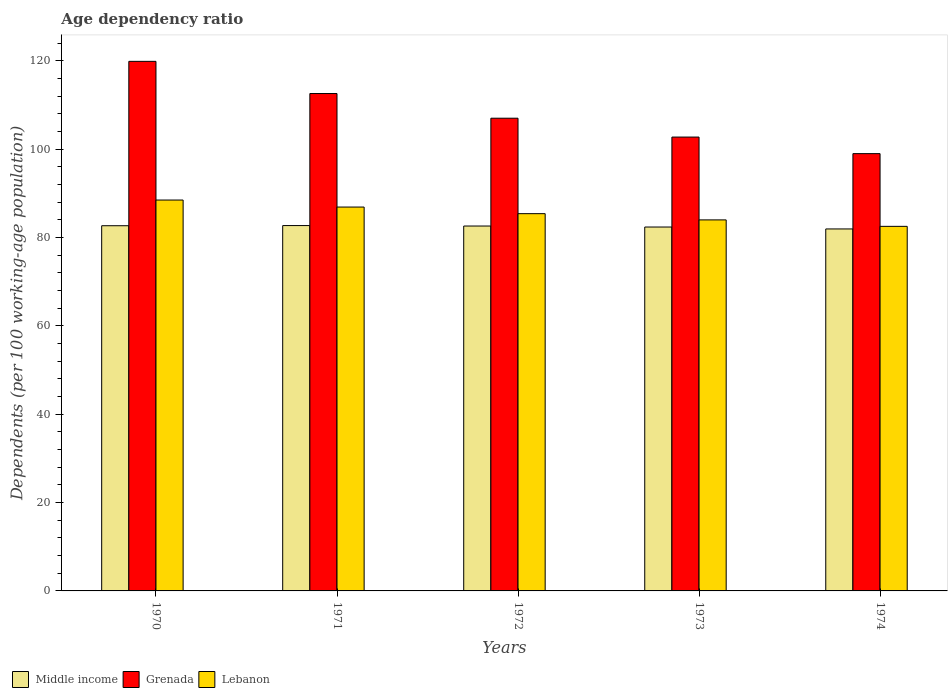How many different coloured bars are there?
Make the answer very short. 3. Are the number of bars per tick equal to the number of legend labels?
Give a very brief answer. Yes. Are the number of bars on each tick of the X-axis equal?
Keep it short and to the point. Yes. How many bars are there on the 4th tick from the right?
Provide a short and direct response. 3. In how many cases, is the number of bars for a given year not equal to the number of legend labels?
Your response must be concise. 0. What is the age dependency ratio in in Grenada in 1970?
Ensure brevity in your answer.  119.88. Across all years, what is the maximum age dependency ratio in in Grenada?
Keep it short and to the point. 119.88. Across all years, what is the minimum age dependency ratio in in Lebanon?
Offer a very short reply. 82.53. In which year was the age dependency ratio in in Lebanon minimum?
Provide a short and direct response. 1974. What is the total age dependency ratio in in Middle income in the graph?
Provide a short and direct response. 412.28. What is the difference between the age dependency ratio in in Middle income in 1972 and that in 1974?
Ensure brevity in your answer.  0.66. What is the difference between the age dependency ratio in in Lebanon in 1974 and the age dependency ratio in in Middle income in 1970?
Provide a short and direct response. -0.14. What is the average age dependency ratio in in Lebanon per year?
Make the answer very short. 85.46. In the year 1974, what is the difference between the age dependency ratio in in Lebanon and age dependency ratio in in Middle income?
Your answer should be compact. 0.59. In how many years, is the age dependency ratio in in Grenada greater than 4 %?
Give a very brief answer. 5. What is the ratio of the age dependency ratio in in Middle income in 1972 to that in 1974?
Ensure brevity in your answer.  1.01. Is the difference between the age dependency ratio in in Lebanon in 1971 and 1974 greater than the difference between the age dependency ratio in in Middle income in 1971 and 1974?
Provide a succinct answer. Yes. What is the difference between the highest and the second highest age dependency ratio in in Middle income?
Ensure brevity in your answer.  0.03. What is the difference between the highest and the lowest age dependency ratio in in Middle income?
Provide a short and direct response. 0.76. In how many years, is the age dependency ratio in in Grenada greater than the average age dependency ratio in in Grenada taken over all years?
Your answer should be very brief. 2. What does the 1st bar from the left in 1972 represents?
Provide a short and direct response. Middle income. Are all the bars in the graph horizontal?
Your response must be concise. No. How many years are there in the graph?
Provide a short and direct response. 5. What is the difference between two consecutive major ticks on the Y-axis?
Ensure brevity in your answer.  20. Does the graph contain any zero values?
Give a very brief answer. No. Where does the legend appear in the graph?
Give a very brief answer. Bottom left. What is the title of the graph?
Offer a very short reply. Age dependency ratio. Does "Timor-Leste" appear as one of the legend labels in the graph?
Keep it short and to the point. No. What is the label or title of the X-axis?
Your answer should be compact. Years. What is the label or title of the Y-axis?
Offer a very short reply. Dependents (per 100 working-age population). What is the Dependents (per 100 working-age population) of Middle income in 1970?
Make the answer very short. 82.67. What is the Dependents (per 100 working-age population) of Grenada in 1970?
Offer a very short reply. 119.88. What is the Dependents (per 100 working-age population) of Lebanon in 1970?
Make the answer very short. 88.48. What is the Dependents (per 100 working-age population) in Middle income in 1971?
Provide a short and direct response. 82.7. What is the Dependents (per 100 working-age population) of Grenada in 1971?
Offer a very short reply. 112.59. What is the Dependents (per 100 working-age population) of Lebanon in 1971?
Keep it short and to the point. 86.89. What is the Dependents (per 100 working-age population) of Middle income in 1972?
Your answer should be very brief. 82.6. What is the Dependents (per 100 working-age population) of Grenada in 1972?
Your answer should be very brief. 107.01. What is the Dependents (per 100 working-age population) in Lebanon in 1972?
Ensure brevity in your answer.  85.4. What is the Dependents (per 100 working-age population) in Middle income in 1973?
Provide a succinct answer. 82.37. What is the Dependents (per 100 working-age population) in Grenada in 1973?
Offer a very short reply. 102.73. What is the Dependents (per 100 working-age population) in Lebanon in 1973?
Give a very brief answer. 83.99. What is the Dependents (per 100 working-age population) in Middle income in 1974?
Provide a short and direct response. 81.94. What is the Dependents (per 100 working-age population) of Grenada in 1974?
Offer a very short reply. 98.99. What is the Dependents (per 100 working-age population) of Lebanon in 1974?
Keep it short and to the point. 82.53. Across all years, what is the maximum Dependents (per 100 working-age population) of Middle income?
Offer a very short reply. 82.7. Across all years, what is the maximum Dependents (per 100 working-age population) of Grenada?
Give a very brief answer. 119.88. Across all years, what is the maximum Dependents (per 100 working-age population) of Lebanon?
Provide a short and direct response. 88.48. Across all years, what is the minimum Dependents (per 100 working-age population) in Middle income?
Make the answer very short. 81.94. Across all years, what is the minimum Dependents (per 100 working-age population) of Grenada?
Offer a terse response. 98.99. Across all years, what is the minimum Dependents (per 100 working-age population) in Lebanon?
Keep it short and to the point. 82.53. What is the total Dependents (per 100 working-age population) of Middle income in the graph?
Keep it short and to the point. 412.28. What is the total Dependents (per 100 working-age population) in Grenada in the graph?
Your answer should be compact. 541.19. What is the total Dependents (per 100 working-age population) of Lebanon in the graph?
Your response must be concise. 427.29. What is the difference between the Dependents (per 100 working-age population) in Middle income in 1970 and that in 1971?
Provide a short and direct response. -0.03. What is the difference between the Dependents (per 100 working-age population) of Grenada in 1970 and that in 1971?
Keep it short and to the point. 7.28. What is the difference between the Dependents (per 100 working-age population) of Lebanon in 1970 and that in 1971?
Provide a short and direct response. 1.59. What is the difference between the Dependents (per 100 working-age population) in Middle income in 1970 and that in 1972?
Your response must be concise. 0.07. What is the difference between the Dependents (per 100 working-age population) of Grenada in 1970 and that in 1972?
Your answer should be very brief. 12.87. What is the difference between the Dependents (per 100 working-age population) of Lebanon in 1970 and that in 1972?
Make the answer very short. 3.08. What is the difference between the Dependents (per 100 working-age population) in Middle income in 1970 and that in 1973?
Provide a succinct answer. 0.29. What is the difference between the Dependents (per 100 working-age population) of Grenada in 1970 and that in 1973?
Provide a succinct answer. 17.14. What is the difference between the Dependents (per 100 working-age population) in Lebanon in 1970 and that in 1973?
Provide a succinct answer. 4.5. What is the difference between the Dependents (per 100 working-age population) in Middle income in 1970 and that in 1974?
Your response must be concise. 0.73. What is the difference between the Dependents (per 100 working-age population) of Grenada in 1970 and that in 1974?
Give a very brief answer. 20.89. What is the difference between the Dependents (per 100 working-age population) of Lebanon in 1970 and that in 1974?
Provide a succinct answer. 5.96. What is the difference between the Dependents (per 100 working-age population) in Middle income in 1971 and that in 1972?
Keep it short and to the point. 0.1. What is the difference between the Dependents (per 100 working-age population) in Grenada in 1971 and that in 1972?
Your answer should be very brief. 5.59. What is the difference between the Dependents (per 100 working-age population) of Lebanon in 1971 and that in 1972?
Your answer should be compact. 1.49. What is the difference between the Dependents (per 100 working-age population) in Middle income in 1971 and that in 1973?
Make the answer very short. 0.33. What is the difference between the Dependents (per 100 working-age population) in Grenada in 1971 and that in 1973?
Provide a short and direct response. 9.86. What is the difference between the Dependents (per 100 working-age population) in Lebanon in 1971 and that in 1973?
Keep it short and to the point. 2.91. What is the difference between the Dependents (per 100 working-age population) of Middle income in 1971 and that in 1974?
Ensure brevity in your answer.  0.76. What is the difference between the Dependents (per 100 working-age population) in Grenada in 1971 and that in 1974?
Keep it short and to the point. 13.61. What is the difference between the Dependents (per 100 working-age population) in Lebanon in 1971 and that in 1974?
Give a very brief answer. 4.37. What is the difference between the Dependents (per 100 working-age population) in Middle income in 1972 and that in 1973?
Offer a terse response. 0.23. What is the difference between the Dependents (per 100 working-age population) in Grenada in 1972 and that in 1973?
Make the answer very short. 4.27. What is the difference between the Dependents (per 100 working-age population) in Lebanon in 1972 and that in 1973?
Provide a succinct answer. 1.41. What is the difference between the Dependents (per 100 working-age population) of Middle income in 1972 and that in 1974?
Offer a very short reply. 0.66. What is the difference between the Dependents (per 100 working-age population) in Grenada in 1972 and that in 1974?
Your response must be concise. 8.02. What is the difference between the Dependents (per 100 working-age population) in Lebanon in 1972 and that in 1974?
Your answer should be very brief. 2.87. What is the difference between the Dependents (per 100 working-age population) in Middle income in 1973 and that in 1974?
Your answer should be very brief. 0.43. What is the difference between the Dependents (per 100 working-age population) of Grenada in 1973 and that in 1974?
Provide a succinct answer. 3.75. What is the difference between the Dependents (per 100 working-age population) of Lebanon in 1973 and that in 1974?
Ensure brevity in your answer.  1.46. What is the difference between the Dependents (per 100 working-age population) of Middle income in 1970 and the Dependents (per 100 working-age population) of Grenada in 1971?
Offer a very short reply. -29.92. What is the difference between the Dependents (per 100 working-age population) of Middle income in 1970 and the Dependents (per 100 working-age population) of Lebanon in 1971?
Your response must be concise. -4.23. What is the difference between the Dependents (per 100 working-age population) in Grenada in 1970 and the Dependents (per 100 working-age population) in Lebanon in 1971?
Your response must be concise. 32.98. What is the difference between the Dependents (per 100 working-age population) of Middle income in 1970 and the Dependents (per 100 working-age population) of Grenada in 1972?
Offer a terse response. -24.34. What is the difference between the Dependents (per 100 working-age population) of Middle income in 1970 and the Dependents (per 100 working-age population) of Lebanon in 1972?
Ensure brevity in your answer.  -2.73. What is the difference between the Dependents (per 100 working-age population) in Grenada in 1970 and the Dependents (per 100 working-age population) in Lebanon in 1972?
Provide a succinct answer. 34.48. What is the difference between the Dependents (per 100 working-age population) in Middle income in 1970 and the Dependents (per 100 working-age population) in Grenada in 1973?
Offer a very short reply. -20.07. What is the difference between the Dependents (per 100 working-age population) of Middle income in 1970 and the Dependents (per 100 working-age population) of Lebanon in 1973?
Make the answer very short. -1.32. What is the difference between the Dependents (per 100 working-age population) of Grenada in 1970 and the Dependents (per 100 working-age population) of Lebanon in 1973?
Ensure brevity in your answer.  35.89. What is the difference between the Dependents (per 100 working-age population) of Middle income in 1970 and the Dependents (per 100 working-age population) of Grenada in 1974?
Offer a terse response. -16.32. What is the difference between the Dependents (per 100 working-age population) in Middle income in 1970 and the Dependents (per 100 working-age population) in Lebanon in 1974?
Your answer should be compact. 0.14. What is the difference between the Dependents (per 100 working-age population) of Grenada in 1970 and the Dependents (per 100 working-age population) of Lebanon in 1974?
Ensure brevity in your answer.  37.35. What is the difference between the Dependents (per 100 working-age population) of Middle income in 1971 and the Dependents (per 100 working-age population) of Grenada in 1972?
Your answer should be compact. -24.3. What is the difference between the Dependents (per 100 working-age population) of Middle income in 1971 and the Dependents (per 100 working-age population) of Lebanon in 1972?
Your response must be concise. -2.7. What is the difference between the Dependents (per 100 working-age population) in Grenada in 1971 and the Dependents (per 100 working-age population) in Lebanon in 1972?
Offer a very short reply. 27.19. What is the difference between the Dependents (per 100 working-age population) of Middle income in 1971 and the Dependents (per 100 working-age population) of Grenada in 1973?
Give a very brief answer. -20.03. What is the difference between the Dependents (per 100 working-age population) in Middle income in 1971 and the Dependents (per 100 working-age population) in Lebanon in 1973?
Give a very brief answer. -1.28. What is the difference between the Dependents (per 100 working-age population) of Grenada in 1971 and the Dependents (per 100 working-age population) of Lebanon in 1973?
Keep it short and to the point. 28.61. What is the difference between the Dependents (per 100 working-age population) of Middle income in 1971 and the Dependents (per 100 working-age population) of Grenada in 1974?
Offer a very short reply. -16.28. What is the difference between the Dependents (per 100 working-age population) in Middle income in 1971 and the Dependents (per 100 working-age population) in Lebanon in 1974?
Provide a succinct answer. 0.17. What is the difference between the Dependents (per 100 working-age population) in Grenada in 1971 and the Dependents (per 100 working-age population) in Lebanon in 1974?
Provide a succinct answer. 30.06. What is the difference between the Dependents (per 100 working-age population) in Middle income in 1972 and the Dependents (per 100 working-age population) in Grenada in 1973?
Ensure brevity in your answer.  -20.13. What is the difference between the Dependents (per 100 working-age population) in Middle income in 1972 and the Dependents (per 100 working-age population) in Lebanon in 1973?
Keep it short and to the point. -1.38. What is the difference between the Dependents (per 100 working-age population) of Grenada in 1972 and the Dependents (per 100 working-age population) of Lebanon in 1973?
Provide a succinct answer. 23.02. What is the difference between the Dependents (per 100 working-age population) of Middle income in 1972 and the Dependents (per 100 working-age population) of Grenada in 1974?
Your answer should be very brief. -16.38. What is the difference between the Dependents (per 100 working-age population) in Middle income in 1972 and the Dependents (per 100 working-age population) in Lebanon in 1974?
Give a very brief answer. 0.08. What is the difference between the Dependents (per 100 working-age population) in Grenada in 1972 and the Dependents (per 100 working-age population) in Lebanon in 1974?
Offer a terse response. 24.48. What is the difference between the Dependents (per 100 working-age population) of Middle income in 1973 and the Dependents (per 100 working-age population) of Grenada in 1974?
Your answer should be very brief. -16.61. What is the difference between the Dependents (per 100 working-age population) of Middle income in 1973 and the Dependents (per 100 working-age population) of Lebanon in 1974?
Provide a short and direct response. -0.15. What is the difference between the Dependents (per 100 working-age population) in Grenada in 1973 and the Dependents (per 100 working-age population) in Lebanon in 1974?
Provide a succinct answer. 20.21. What is the average Dependents (per 100 working-age population) of Middle income per year?
Provide a short and direct response. 82.46. What is the average Dependents (per 100 working-age population) of Grenada per year?
Your answer should be very brief. 108.24. What is the average Dependents (per 100 working-age population) in Lebanon per year?
Keep it short and to the point. 85.46. In the year 1970, what is the difference between the Dependents (per 100 working-age population) of Middle income and Dependents (per 100 working-age population) of Grenada?
Your answer should be compact. -37.21. In the year 1970, what is the difference between the Dependents (per 100 working-age population) of Middle income and Dependents (per 100 working-age population) of Lebanon?
Your answer should be compact. -5.82. In the year 1970, what is the difference between the Dependents (per 100 working-age population) of Grenada and Dependents (per 100 working-age population) of Lebanon?
Offer a very short reply. 31.39. In the year 1971, what is the difference between the Dependents (per 100 working-age population) in Middle income and Dependents (per 100 working-age population) in Grenada?
Your answer should be very brief. -29.89. In the year 1971, what is the difference between the Dependents (per 100 working-age population) of Middle income and Dependents (per 100 working-age population) of Lebanon?
Your answer should be compact. -4.19. In the year 1971, what is the difference between the Dependents (per 100 working-age population) in Grenada and Dependents (per 100 working-age population) in Lebanon?
Keep it short and to the point. 25.7. In the year 1972, what is the difference between the Dependents (per 100 working-age population) in Middle income and Dependents (per 100 working-age population) in Grenada?
Your answer should be compact. -24.4. In the year 1972, what is the difference between the Dependents (per 100 working-age population) of Middle income and Dependents (per 100 working-age population) of Lebanon?
Your response must be concise. -2.8. In the year 1972, what is the difference between the Dependents (per 100 working-age population) of Grenada and Dependents (per 100 working-age population) of Lebanon?
Provide a succinct answer. 21.61. In the year 1973, what is the difference between the Dependents (per 100 working-age population) in Middle income and Dependents (per 100 working-age population) in Grenada?
Offer a very short reply. -20.36. In the year 1973, what is the difference between the Dependents (per 100 working-age population) in Middle income and Dependents (per 100 working-age population) in Lebanon?
Give a very brief answer. -1.61. In the year 1973, what is the difference between the Dependents (per 100 working-age population) of Grenada and Dependents (per 100 working-age population) of Lebanon?
Offer a very short reply. 18.75. In the year 1974, what is the difference between the Dependents (per 100 working-age population) in Middle income and Dependents (per 100 working-age population) in Grenada?
Your response must be concise. -17.05. In the year 1974, what is the difference between the Dependents (per 100 working-age population) of Middle income and Dependents (per 100 working-age population) of Lebanon?
Offer a very short reply. -0.59. In the year 1974, what is the difference between the Dependents (per 100 working-age population) of Grenada and Dependents (per 100 working-age population) of Lebanon?
Your answer should be compact. 16.46. What is the ratio of the Dependents (per 100 working-age population) in Grenada in 1970 to that in 1971?
Your answer should be compact. 1.06. What is the ratio of the Dependents (per 100 working-age population) in Lebanon in 1970 to that in 1971?
Your answer should be compact. 1.02. What is the ratio of the Dependents (per 100 working-age population) in Middle income in 1970 to that in 1972?
Give a very brief answer. 1. What is the ratio of the Dependents (per 100 working-age population) of Grenada in 1970 to that in 1972?
Give a very brief answer. 1.12. What is the ratio of the Dependents (per 100 working-age population) of Lebanon in 1970 to that in 1972?
Your answer should be compact. 1.04. What is the ratio of the Dependents (per 100 working-age population) in Grenada in 1970 to that in 1973?
Provide a short and direct response. 1.17. What is the ratio of the Dependents (per 100 working-age population) in Lebanon in 1970 to that in 1973?
Your answer should be very brief. 1.05. What is the ratio of the Dependents (per 100 working-age population) of Middle income in 1970 to that in 1974?
Provide a short and direct response. 1.01. What is the ratio of the Dependents (per 100 working-age population) in Grenada in 1970 to that in 1974?
Keep it short and to the point. 1.21. What is the ratio of the Dependents (per 100 working-age population) of Lebanon in 1970 to that in 1974?
Your answer should be compact. 1.07. What is the ratio of the Dependents (per 100 working-age population) in Grenada in 1971 to that in 1972?
Your answer should be compact. 1.05. What is the ratio of the Dependents (per 100 working-age population) of Lebanon in 1971 to that in 1972?
Make the answer very short. 1.02. What is the ratio of the Dependents (per 100 working-age population) in Middle income in 1971 to that in 1973?
Provide a short and direct response. 1. What is the ratio of the Dependents (per 100 working-age population) of Grenada in 1971 to that in 1973?
Your answer should be compact. 1.1. What is the ratio of the Dependents (per 100 working-age population) in Lebanon in 1971 to that in 1973?
Your answer should be very brief. 1.03. What is the ratio of the Dependents (per 100 working-age population) of Middle income in 1971 to that in 1974?
Your response must be concise. 1.01. What is the ratio of the Dependents (per 100 working-age population) in Grenada in 1971 to that in 1974?
Make the answer very short. 1.14. What is the ratio of the Dependents (per 100 working-age population) of Lebanon in 1971 to that in 1974?
Offer a very short reply. 1.05. What is the ratio of the Dependents (per 100 working-age population) of Grenada in 1972 to that in 1973?
Make the answer very short. 1.04. What is the ratio of the Dependents (per 100 working-age population) in Lebanon in 1972 to that in 1973?
Ensure brevity in your answer.  1.02. What is the ratio of the Dependents (per 100 working-age population) in Middle income in 1972 to that in 1974?
Keep it short and to the point. 1.01. What is the ratio of the Dependents (per 100 working-age population) of Grenada in 1972 to that in 1974?
Ensure brevity in your answer.  1.08. What is the ratio of the Dependents (per 100 working-age population) in Lebanon in 1972 to that in 1974?
Give a very brief answer. 1.03. What is the ratio of the Dependents (per 100 working-age population) in Grenada in 1973 to that in 1974?
Offer a very short reply. 1.04. What is the ratio of the Dependents (per 100 working-age population) of Lebanon in 1973 to that in 1974?
Your answer should be very brief. 1.02. What is the difference between the highest and the second highest Dependents (per 100 working-age population) of Middle income?
Your response must be concise. 0.03. What is the difference between the highest and the second highest Dependents (per 100 working-age population) in Grenada?
Ensure brevity in your answer.  7.28. What is the difference between the highest and the second highest Dependents (per 100 working-age population) in Lebanon?
Your answer should be very brief. 1.59. What is the difference between the highest and the lowest Dependents (per 100 working-age population) of Middle income?
Give a very brief answer. 0.76. What is the difference between the highest and the lowest Dependents (per 100 working-age population) in Grenada?
Provide a short and direct response. 20.89. What is the difference between the highest and the lowest Dependents (per 100 working-age population) in Lebanon?
Provide a succinct answer. 5.96. 